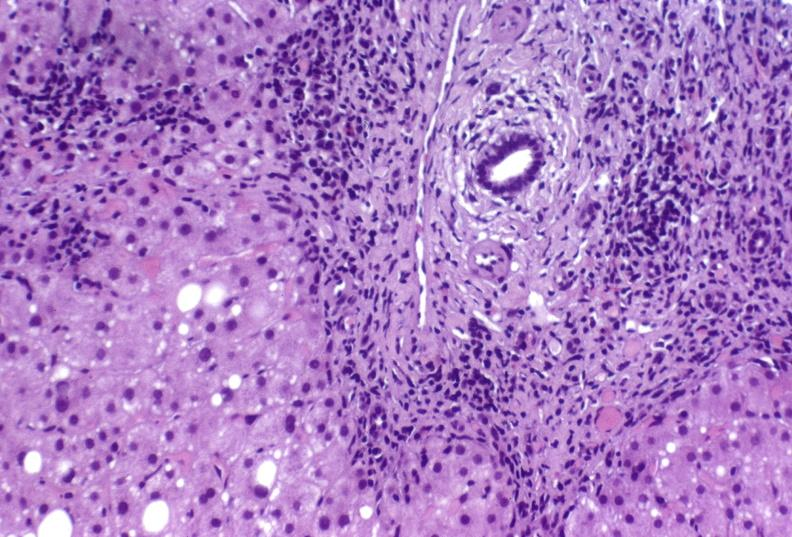s nuclear change present?
Answer the question using a single word or phrase. No 